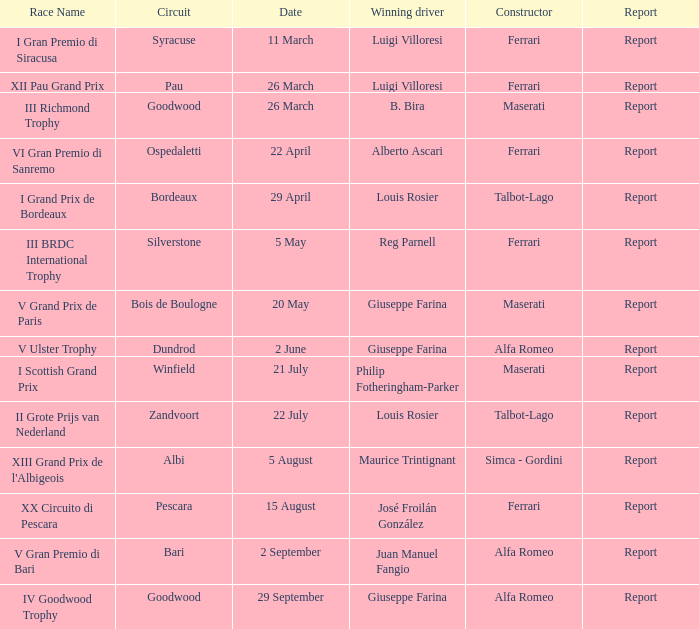What is the title of the report from may 20th? Report. 